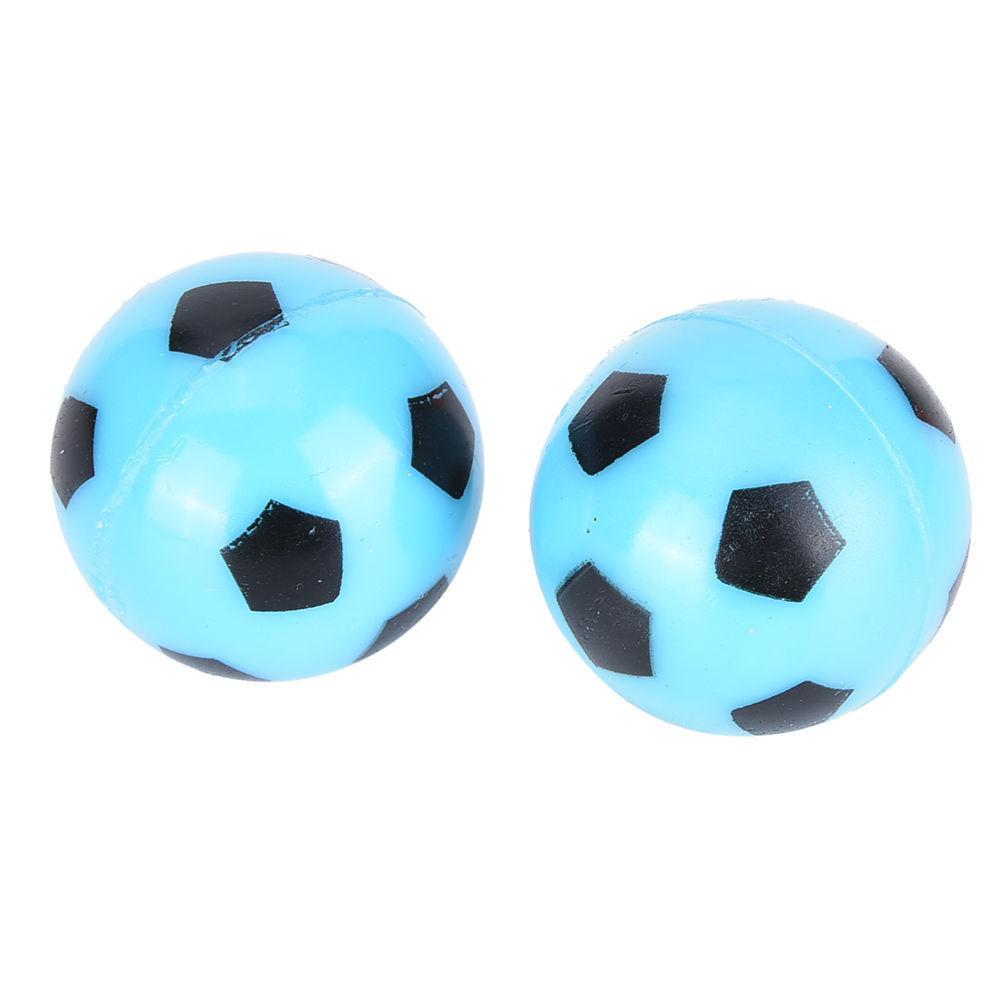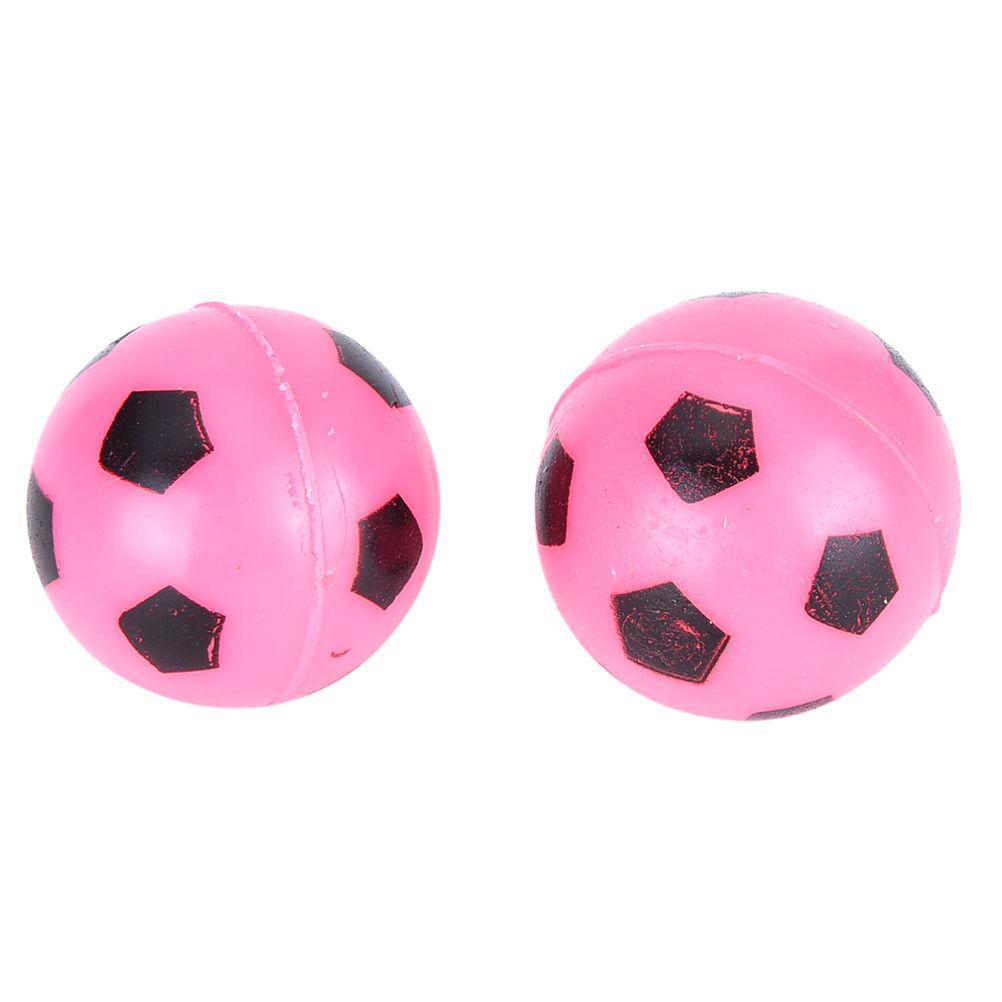The first image is the image on the left, the second image is the image on the right. Examine the images to the left and right. Is the description "There are more than 3 balls painted like soccer balls, and there are no numbers on any of them." accurate? Answer yes or no. Yes. The first image is the image on the left, the second image is the image on the right. Analyze the images presented: Is the assertion "Two of the soccer balls are pink." valid? Answer yes or no. Yes. 